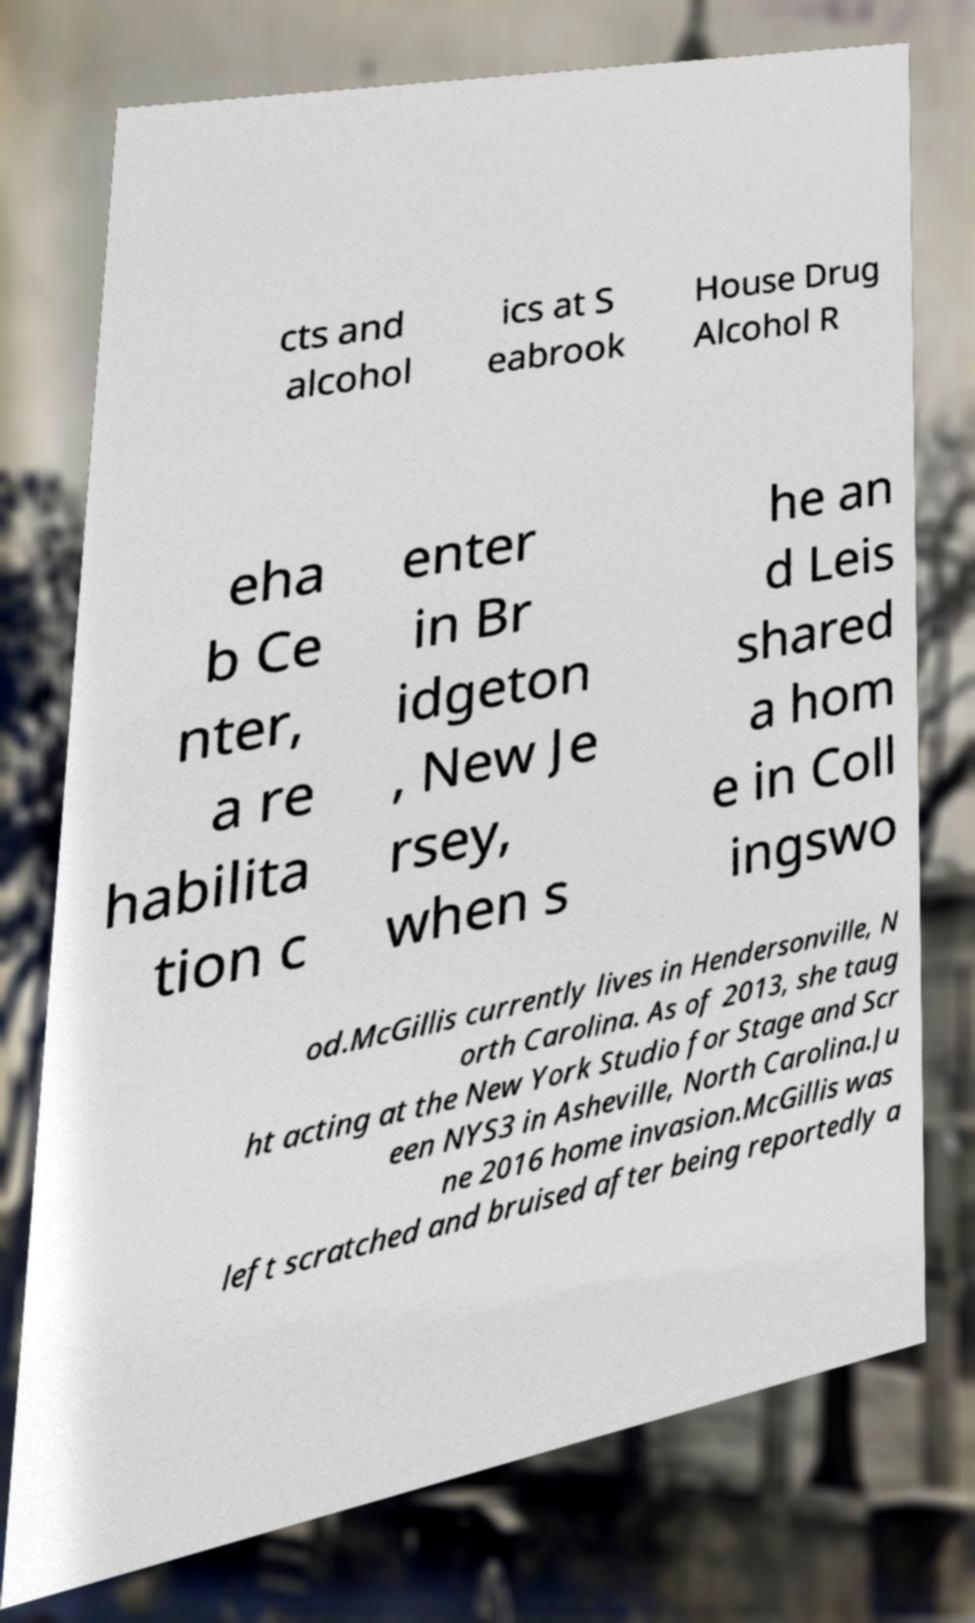Could you assist in decoding the text presented in this image and type it out clearly? cts and alcohol ics at S eabrook House Drug Alcohol R eha b Ce nter, a re habilita tion c enter in Br idgeton , New Je rsey, when s he an d Leis shared a hom e in Coll ingswo od.McGillis currently lives in Hendersonville, N orth Carolina. As of 2013, she taug ht acting at the New York Studio for Stage and Scr een NYS3 in Asheville, North Carolina.Ju ne 2016 home invasion.McGillis was left scratched and bruised after being reportedly a 